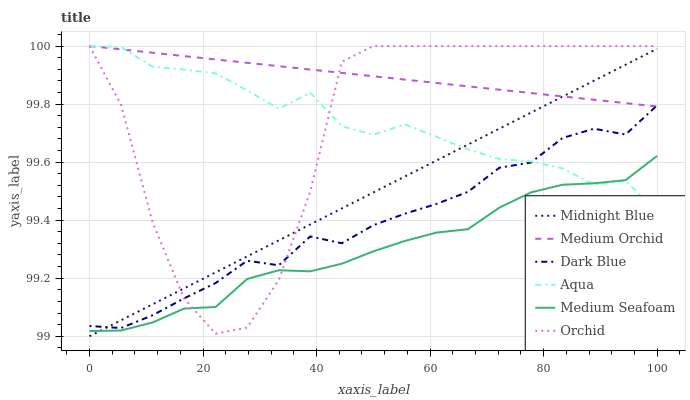Does Medium Seafoam have the minimum area under the curve?
Answer yes or no. Yes. Does Medium Orchid have the maximum area under the curve?
Answer yes or no. Yes. Does Aqua have the minimum area under the curve?
Answer yes or no. No. Does Aqua have the maximum area under the curve?
Answer yes or no. No. Is Medium Orchid the smoothest?
Answer yes or no. Yes. Is Orchid the roughest?
Answer yes or no. Yes. Is Aqua the smoothest?
Answer yes or no. No. Is Aqua the roughest?
Answer yes or no. No. Does Midnight Blue have the lowest value?
Answer yes or no. Yes. Does Aqua have the lowest value?
Answer yes or no. No. Does Orchid have the highest value?
Answer yes or no. Yes. Does Dark Blue have the highest value?
Answer yes or no. No. Is Medium Seafoam less than Dark Blue?
Answer yes or no. Yes. Is Dark Blue greater than Medium Seafoam?
Answer yes or no. Yes. Does Aqua intersect Midnight Blue?
Answer yes or no. Yes. Is Aqua less than Midnight Blue?
Answer yes or no. No. Is Aqua greater than Midnight Blue?
Answer yes or no. No. Does Medium Seafoam intersect Dark Blue?
Answer yes or no. No. 